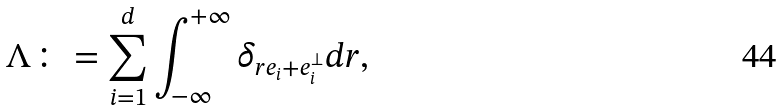Convert formula to latex. <formula><loc_0><loc_0><loc_500><loc_500>\Lambda \colon = \sum _ { i = 1 } ^ { d } \int _ { - \infty } ^ { + \infty } \delta _ { r e _ { i } + e _ { i } ^ { \bot } } d r ,</formula> 